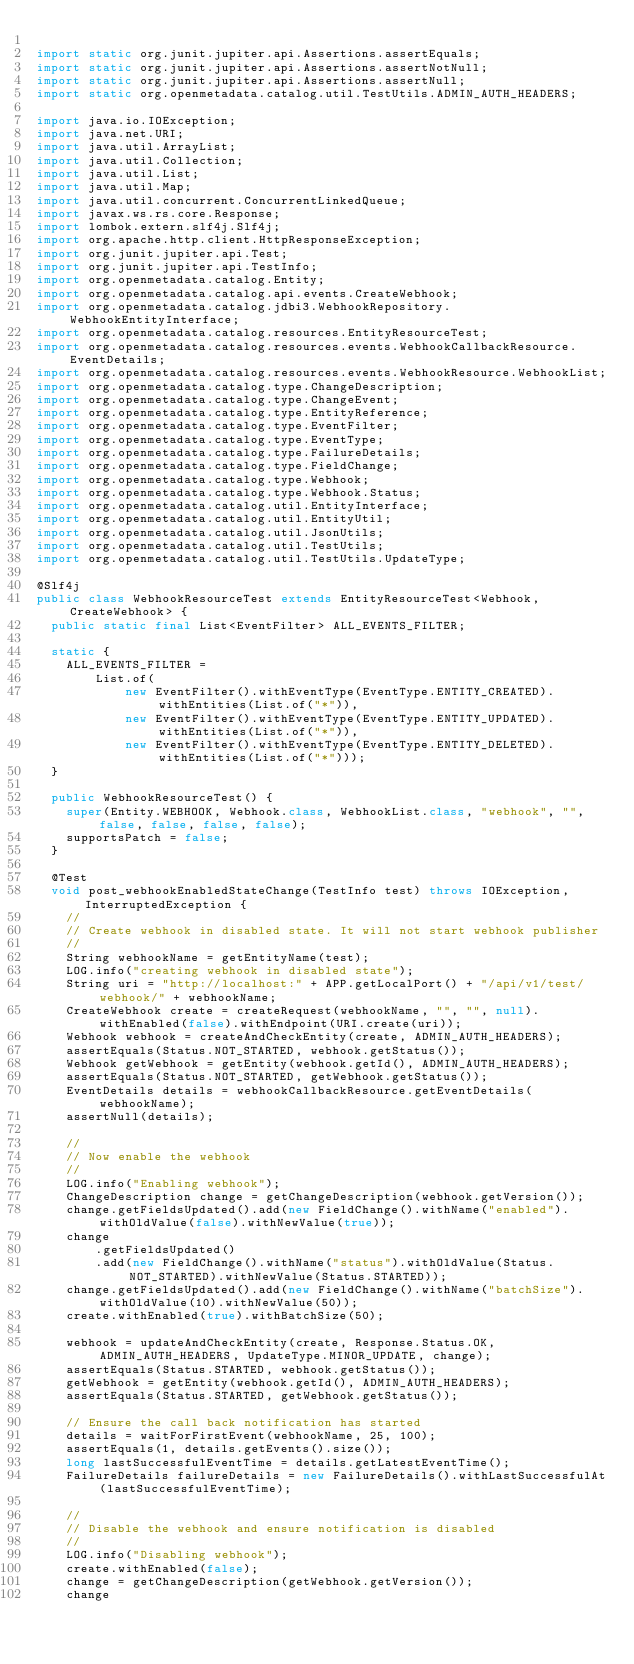Convert code to text. <code><loc_0><loc_0><loc_500><loc_500><_Java_>
import static org.junit.jupiter.api.Assertions.assertEquals;
import static org.junit.jupiter.api.Assertions.assertNotNull;
import static org.junit.jupiter.api.Assertions.assertNull;
import static org.openmetadata.catalog.util.TestUtils.ADMIN_AUTH_HEADERS;

import java.io.IOException;
import java.net.URI;
import java.util.ArrayList;
import java.util.Collection;
import java.util.List;
import java.util.Map;
import java.util.concurrent.ConcurrentLinkedQueue;
import javax.ws.rs.core.Response;
import lombok.extern.slf4j.Slf4j;
import org.apache.http.client.HttpResponseException;
import org.junit.jupiter.api.Test;
import org.junit.jupiter.api.TestInfo;
import org.openmetadata.catalog.Entity;
import org.openmetadata.catalog.api.events.CreateWebhook;
import org.openmetadata.catalog.jdbi3.WebhookRepository.WebhookEntityInterface;
import org.openmetadata.catalog.resources.EntityResourceTest;
import org.openmetadata.catalog.resources.events.WebhookCallbackResource.EventDetails;
import org.openmetadata.catalog.resources.events.WebhookResource.WebhookList;
import org.openmetadata.catalog.type.ChangeDescription;
import org.openmetadata.catalog.type.ChangeEvent;
import org.openmetadata.catalog.type.EntityReference;
import org.openmetadata.catalog.type.EventFilter;
import org.openmetadata.catalog.type.EventType;
import org.openmetadata.catalog.type.FailureDetails;
import org.openmetadata.catalog.type.FieldChange;
import org.openmetadata.catalog.type.Webhook;
import org.openmetadata.catalog.type.Webhook.Status;
import org.openmetadata.catalog.util.EntityInterface;
import org.openmetadata.catalog.util.EntityUtil;
import org.openmetadata.catalog.util.JsonUtils;
import org.openmetadata.catalog.util.TestUtils;
import org.openmetadata.catalog.util.TestUtils.UpdateType;

@Slf4j
public class WebhookResourceTest extends EntityResourceTest<Webhook, CreateWebhook> {
  public static final List<EventFilter> ALL_EVENTS_FILTER;

  static {
    ALL_EVENTS_FILTER =
        List.of(
            new EventFilter().withEventType(EventType.ENTITY_CREATED).withEntities(List.of("*")),
            new EventFilter().withEventType(EventType.ENTITY_UPDATED).withEntities(List.of("*")),
            new EventFilter().withEventType(EventType.ENTITY_DELETED).withEntities(List.of("*")));
  }

  public WebhookResourceTest() {
    super(Entity.WEBHOOK, Webhook.class, WebhookList.class, "webhook", "", false, false, false, false);
    supportsPatch = false;
  }

  @Test
  void post_webhookEnabledStateChange(TestInfo test) throws IOException, InterruptedException {
    //
    // Create webhook in disabled state. It will not start webhook publisher
    //
    String webhookName = getEntityName(test);
    LOG.info("creating webhook in disabled state");
    String uri = "http://localhost:" + APP.getLocalPort() + "/api/v1/test/webhook/" + webhookName;
    CreateWebhook create = createRequest(webhookName, "", "", null).withEnabled(false).withEndpoint(URI.create(uri));
    Webhook webhook = createAndCheckEntity(create, ADMIN_AUTH_HEADERS);
    assertEquals(Status.NOT_STARTED, webhook.getStatus());
    Webhook getWebhook = getEntity(webhook.getId(), ADMIN_AUTH_HEADERS);
    assertEquals(Status.NOT_STARTED, getWebhook.getStatus());
    EventDetails details = webhookCallbackResource.getEventDetails(webhookName);
    assertNull(details);

    //
    // Now enable the webhook
    //
    LOG.info("Enabling webhook");
    ChangeDescription change = getChangeDescription(webhook.getVersion());
    change.getFieldsUpdated().add(new FieldChange().withName("enabled").withOldValue(false).withNewValue(true));
    change
        .getFieldsUpdated()
        .add(new FieldChange().withName("status").withOldValue(Status.NOT_STARTED).withNewValue(Status.STARTED));
    change.getFieldsUpdated().add(new FieldChange().withName("batchSize").withOldValue(10).withNewValue(50));
    create.withEnabled(true).withBatchSize(50);

    webhook = updateAndCheckEntity(create, Response.Status.OK, ADMIN_AUTH_HEADERS, UpdateType.MINOR_UPDATE, change);
    assertEquals(Status.STARTED, webhook.getStatus());
    getWebhook = getEntity(webhook.getId(), ADMIN_AUTH_HEADERS);
    assertEquals(Status.STARTED, getWebhook.getStatus());

    // Ensure the call back notification has started
    details = waitForFirstEvent(webhookName, 25, 100);
    assertEquals(1, details.getEvents().size());
    long lastSuccessfulEventTime = details.getLatestEventTime();
    FailureDetails failureDetails = new FailureDetails().withLastSuccessfulAt(lastSuccessfulEventTime);

    //
    // Disable the webhook and ensure notification is disabled
    //
    LOG.info("Disabling webhook");
    create.withEnabled(false);
    change = getChangeDescription(getWebhook.getVersion());
    change</code> 